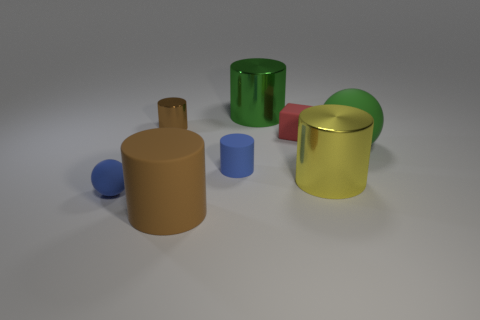What is the shape of the yellow shiny thing? cylinder 